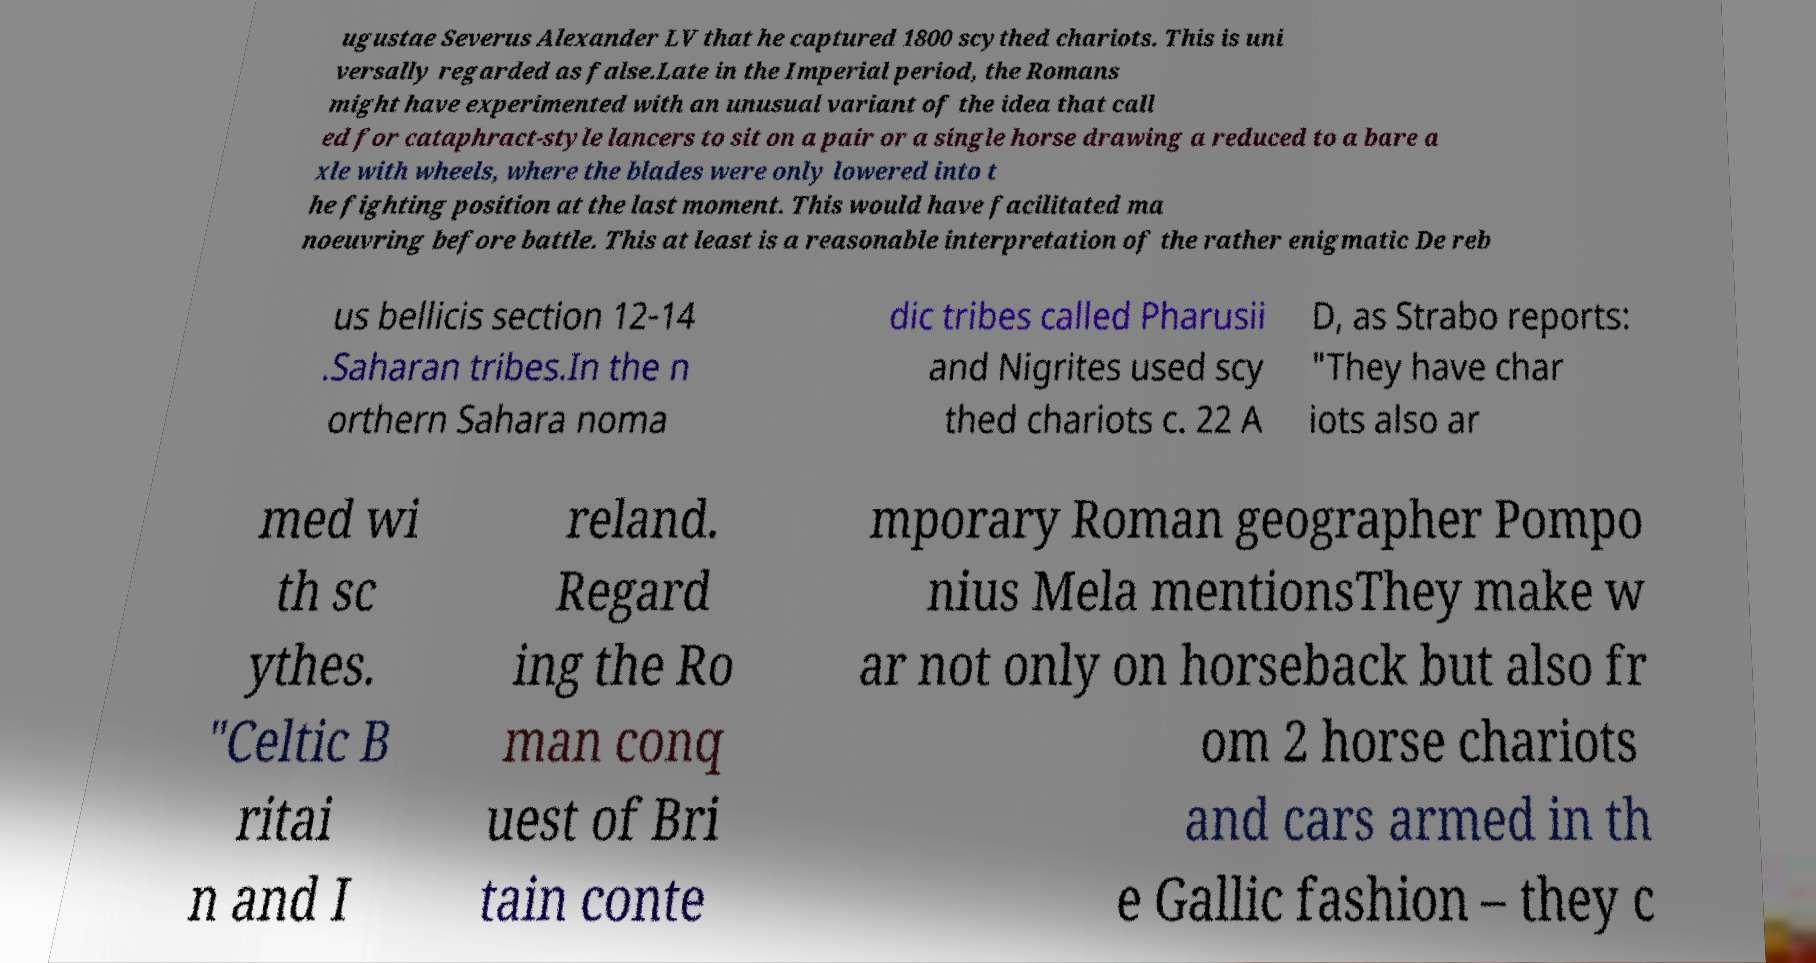Can you accurately transcribe the text from the provided image for me? ugustae Severus Alexander LV that he captured 1800 scythed chariots. This is uni versally regarded as false.Late in the Imperial period, the Romans might have experimented with an unusual variant of the idea that call ed for cataphract-style lancers to sit on a pair or a single horse drawing a reduced to a bare a xle with wheels, where the blades were only lowered into t he fighting position at the last moment. This would have facilitated ma noeuvring before battle. This at least is a reasonable interpretation of the rather enigmatic De reb us bellicis section 12-14 .Saharan tribes.In the n orthern Sahara noma dic tribes called Pharusii and Nigrites used scy thed chariots c. 22 A D, as Strabo reports: "They have char iots also ar med wi th sc ythes. "Celtic B ritai n and I reland. Regard ing the Ro man conq uest of Bri tain conte mporary Roman geographer Pompo nius Mela mentionsThey make w ar not only on horseback but also fr om 2 horse chariots and cars armed in th e Gallic fashion – they c 